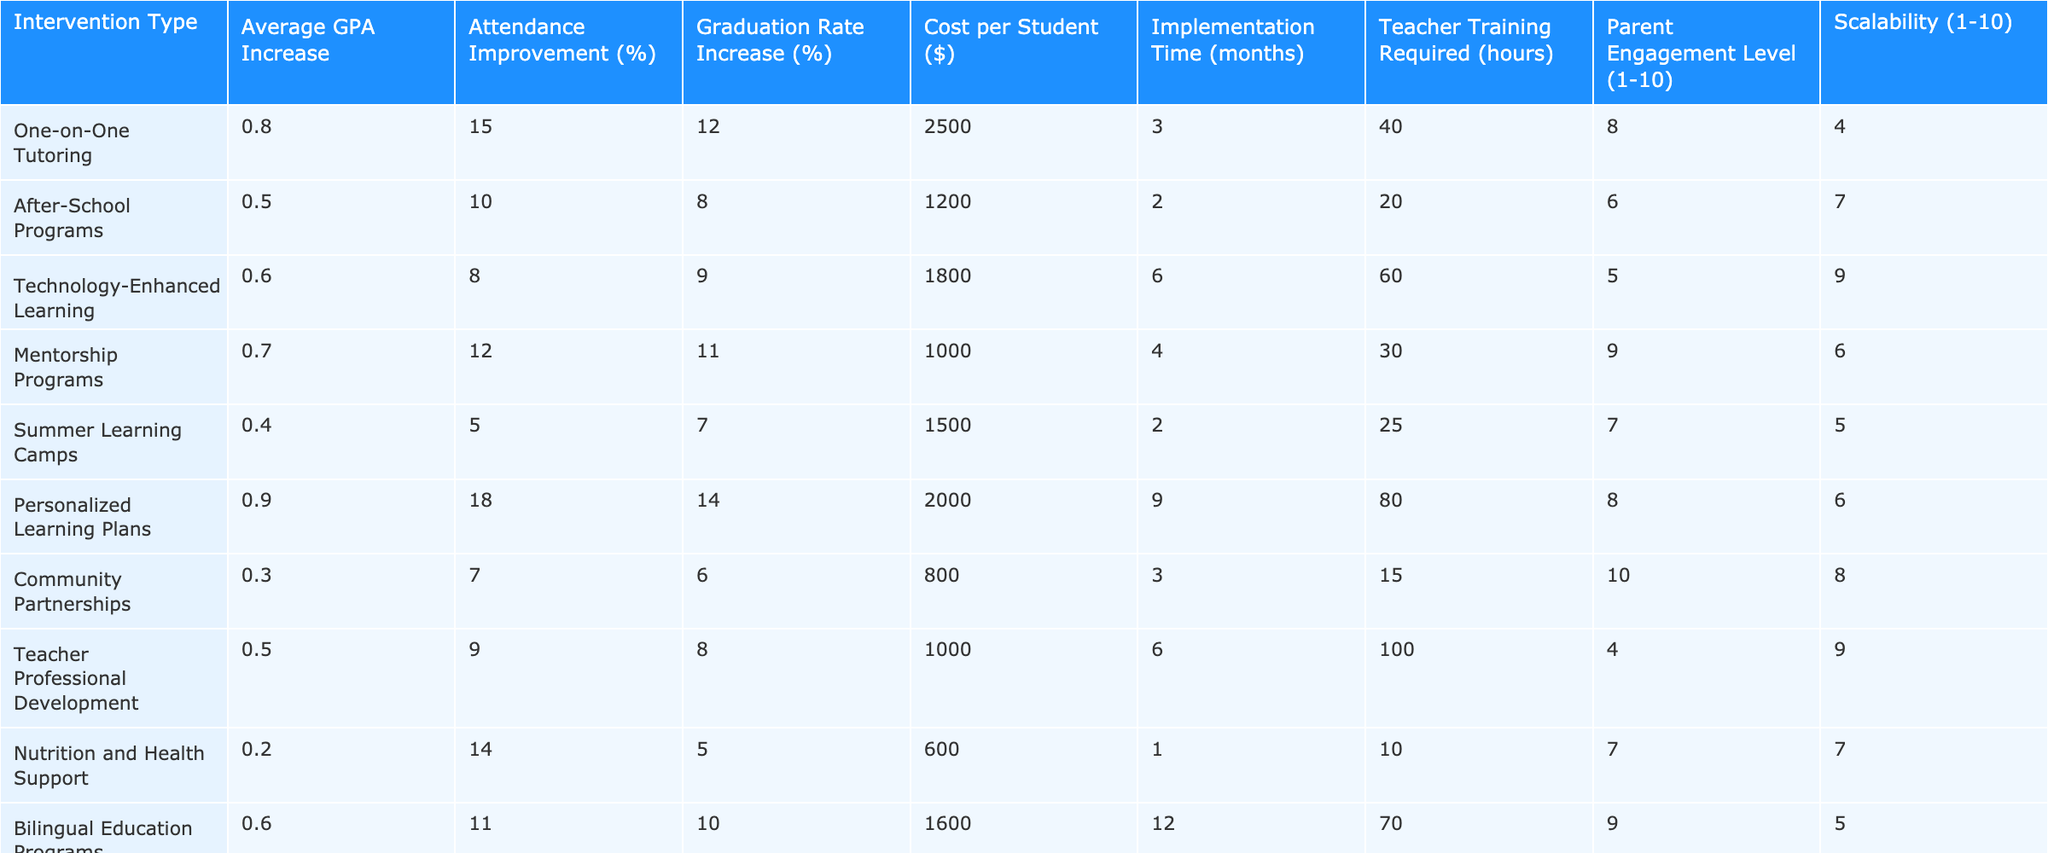What is the average GPA increase for One-on-One Tutoring? From the table, the row for One-on-One Tutoring shows the Average GPA Increase value as 0.8. Therefore, this is the direct answer from the data provided.
Answer: 0.8 What is the implementation time in months for Technology-Enhanced Learning? Looking at the row for Technology-Enhanced Learning, the Implementation Time is listed as 6 months. This is a straightforward retrieval from the table.
Answer: 6 Which intervention has the highest cost per student? By comparing all values in the Cost per Student column, we find that the Personalized Learning Plans have the highest cost at $2000, as it is greater than all other listed interventions.
Answer: $2000 Is the Attendance Improvement for Summer Learning Camps greater than 10%? From the row related to Summer Learning Camps, Attendance Improvement is noted as 5%. Since 5% is less than 10%, the answer is no.
Answer: No What is the difference in average GPA increase between Personal Learning Plans and Community Partnerships? To find the difference, first identify the Average GPA Increase for both: Personal Learning Plans is 0.9 and Community Partnerships is 0.3. Subtract: 0.9 - 0.3 = 0.6, indicating that Personal Learning Plans have a significantly higher average increase.
Answer: 0.6 Which interventions require more than 50 hours of teacher training? By reviewing the Teacher Training Required column, we find that Personalized Learning Plans (80 hours) and Teacher Professional Development (100 hours) require more than 50 hours. Therefore, both interventions meet this criterion.
Answer: Personalized Learning Plans, Teacher Professional Development Calculate the average attendance improvement across all interventions. To compute the average, sum the Attendance Improvement values (15 + 10 + 8 + 12 + 5 + 18 + 7 + 9 + 14 + 11) = 99. Given there are 10 interventions, divide by 10 to get the average: 99/10 = 9.9%.
Answer: 9.9% Is the Graduation Rate Increase for After-School Programs lower than that for Nutrition and Health Support? The Graduation Rate Increase for After-School Programs is 8% and for Nutrition and Health Support, it is 5%. Since 8% is greater than 5%, the statement is false.
Answer: No What is the scaling capability rating (1-10) for Technology-Enhanced Learning? Referring to the row for Technology-Enhanced Learning, the Scalability is noted as 9, indicating it has a high scalability capability compared to other interventions.
Answer: 9 